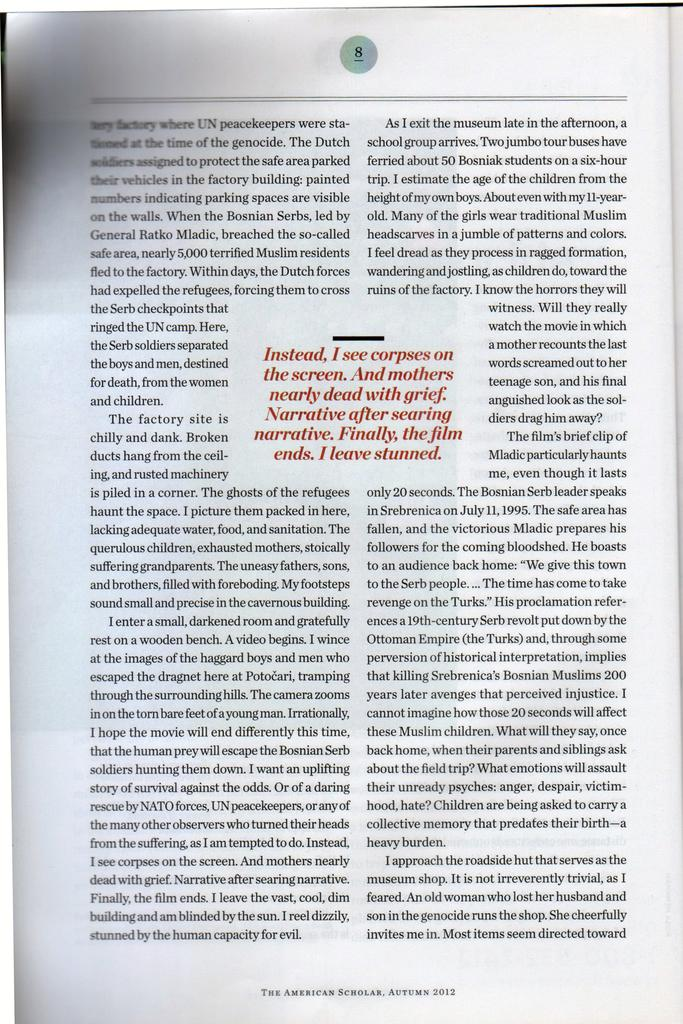<image>
Render a clear and concise summary of the photo. A book is open to page 8 and a section in the middle begins with the words "Instead, I see corpses on the screen." 